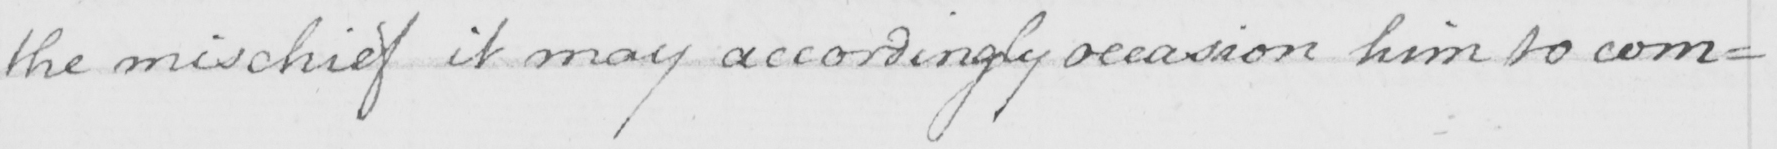What is written in this line of handwriting? the mischief it may accordingly occasion him to com= 